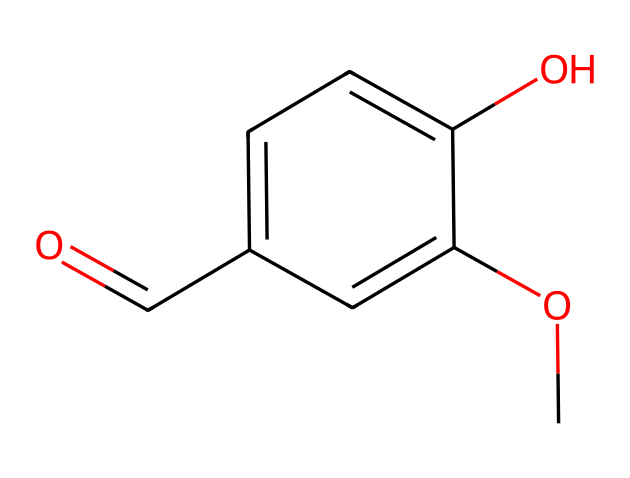What is the molecular formula of vanillin? To determine the molecular formula, we can analyze the SMILES representation. Counting the atoms shown, we find 8 carbon (C) atoms, 8 hydrogen (H) atoms, and 3 oxygen (O) atoms. Thus, the molecular formula is expressed as C8H8O3.
Answer: C8H8O3 How many hydroxyl groups are present in this molecule? The chemical structure shows a -OH group attached to the aromatic ring, indicating the presence of one hydroxyl group.
Answer: 1 What type of functional group is present in vanillin? In the structure, we can identify a carbonyl group (O=C) along with the -OH group, which together indicate the presence of an aldehyde functional group.
Answer: aldehyde What is the total number of rings in the structure? An examination of the chemical structure reveals that the aromatic part is a single ring in the molecule; thus, the total number of rings is one.
Answer: 1 Which substituents are present on the aromatic ring? By observing the positions of the -OH and -OCH3 groups, we can identify that vanillin has a hydroxyl (-OH) and a methoxy (-OCH3) substituent attached to the benzene ring.
Answer: -OH and -OCH3 How does the presence of the aldehyde group influence the odor of vanillin? Aldehyde functional groups, particularly in compounds like vanillin, are well-known for providing sweet, warm, and pleasant aromas, thereby significantly contributing to its characteristic fragrance.
Answer: sweet 